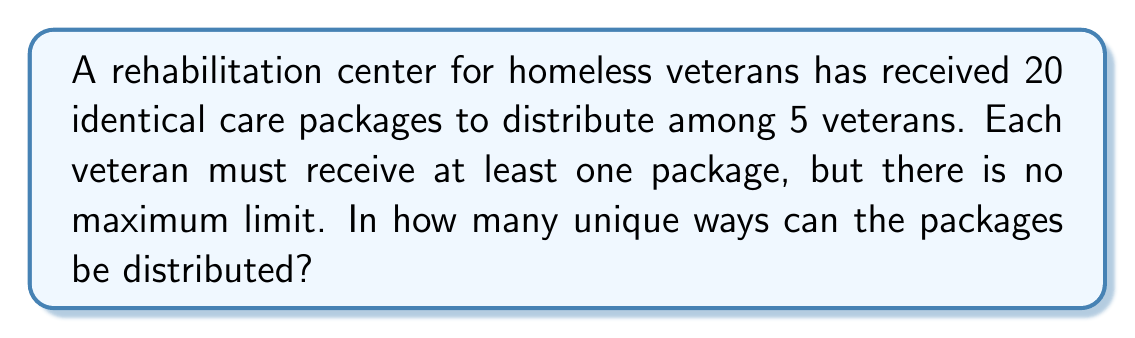Could you help me with this problem? Let's approach this step-by-step:

1) This is a classic stars and bars problem. We need to distribute 20 identical objects (packages) into 5 distinct groups (veterans).

2) The formula for this scenario is:

   $${n+k-1 \choose k-1}$$

   Where $n$ is the number of identical objects and $k$ is the number of distinct groups.

3) In this case, $n = 20$ (packages) and $k = 5$ (veterans).

4) Substituting these values into the formula:

   $${20+5-1 \choose 5-1} = {24 \choose 4}$$

5) Now we need to calculate this combination:

   $${24 \choose 4} = \frac{24!}{4!(24-4)!} = \frac{24!}{4!20!}$$

6) Expanding this:
   
   $$\frac{24 \times 23 \times 22 \times 21}{4 \times 3 \times 2 \times 1} = 10,626$$

Therefore, there are 10,626 unique ways to distribute the packages.
Answer: 10,626 